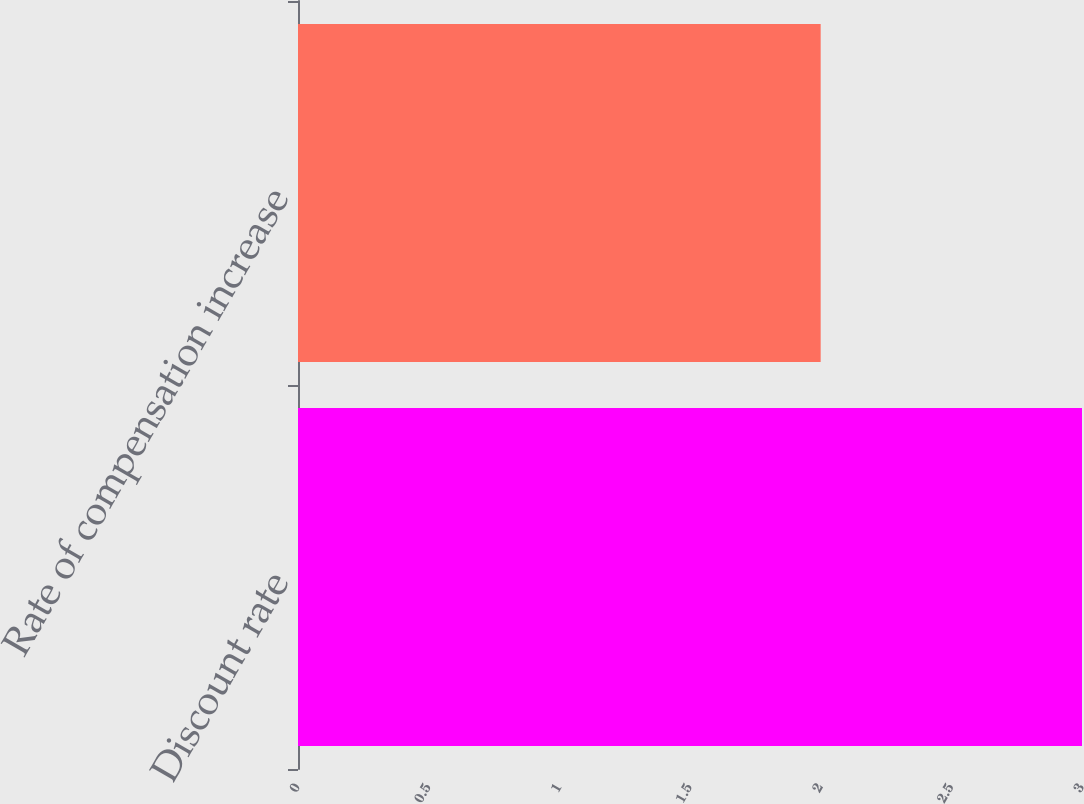<chart> <loc_0><loc_0><loc_500><loc_500><bar_chart><fcel>Discount rate<fcel>Rate of compensation increase<nl><fcel>3<fcel>2<nl></chart> 